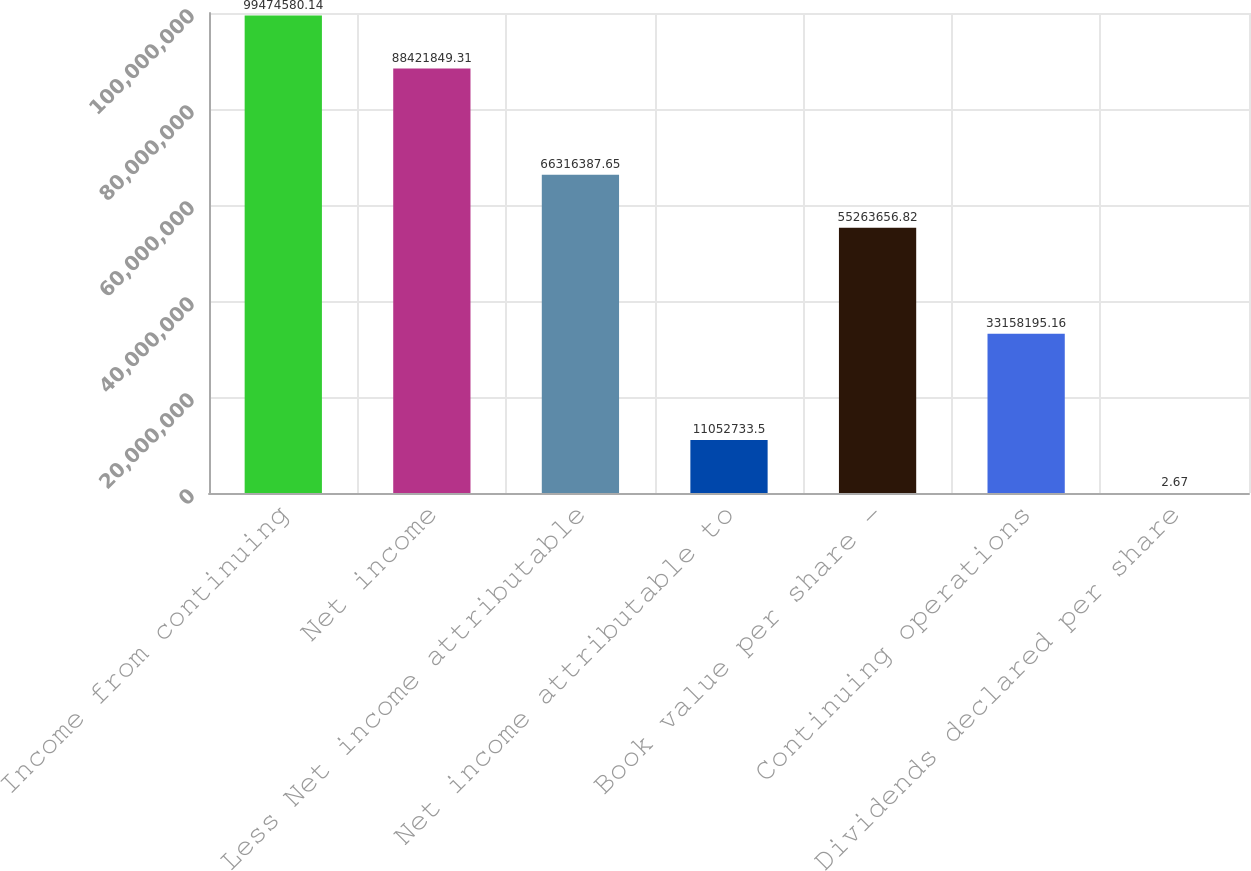<chart> <loc_0><loc_0><loc_500><loc_500><bar_chart><fcel>Income from continuing<fcel>Net income<fcel>Less Net income attributable<fcel>Net income attributable to<fcel>Book value per share -<fcel>Continuing operations<fcel>Dividends declared per share<nl><fcel>9.94746e+07<fcel>8.84218e+07<fcel>6.63164e+07<fcel>1.10527e+07<fcel>5.52637e+07<fcel>3.31582e+07<fcel>2.67<nl></chart> 